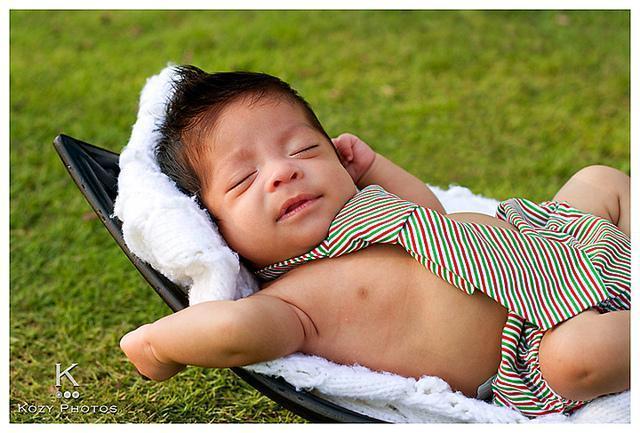How many train cars can be seen?
Give a very brief answer. 0. 